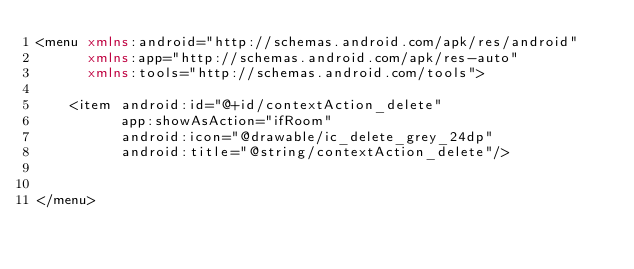<code> <loc_0><loc_0><loc_500><loc_500><_XML_><menu xmlns:android="http://schemas.android.com/apk/res/android"
      xmlns:app="http://schemas.android.com/apk/res-auto"
      xmlns:tools="http://schemas.android.com/tools">

    <item android:id="@+id/contextAction_delete"
          app:showAsAction="ifRoom"
          android:icon="@drawable/ic_delete_grey_24dp"
          android:title="@string/contextAction_delete"/>


</menu></code> 